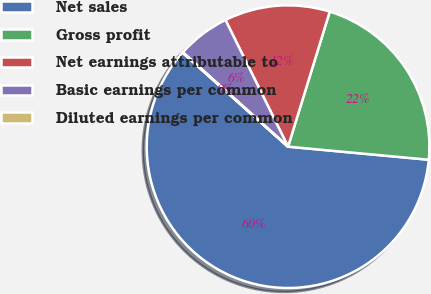Convert chart to OTSL. <chart><loc_0><loc_0><loc_500><loc_500><pie_chart><fcel>Net sales<fcel>Gross profit<fcel>Net earnings attributable to<fcel>Basic earnings per common<fcel>Diluted earnings per common<nl><fcel>60.11%<fcel>21.71%<fcel>12.07%<fcel>6.06%<fcel>0.06%<nl></chart> 